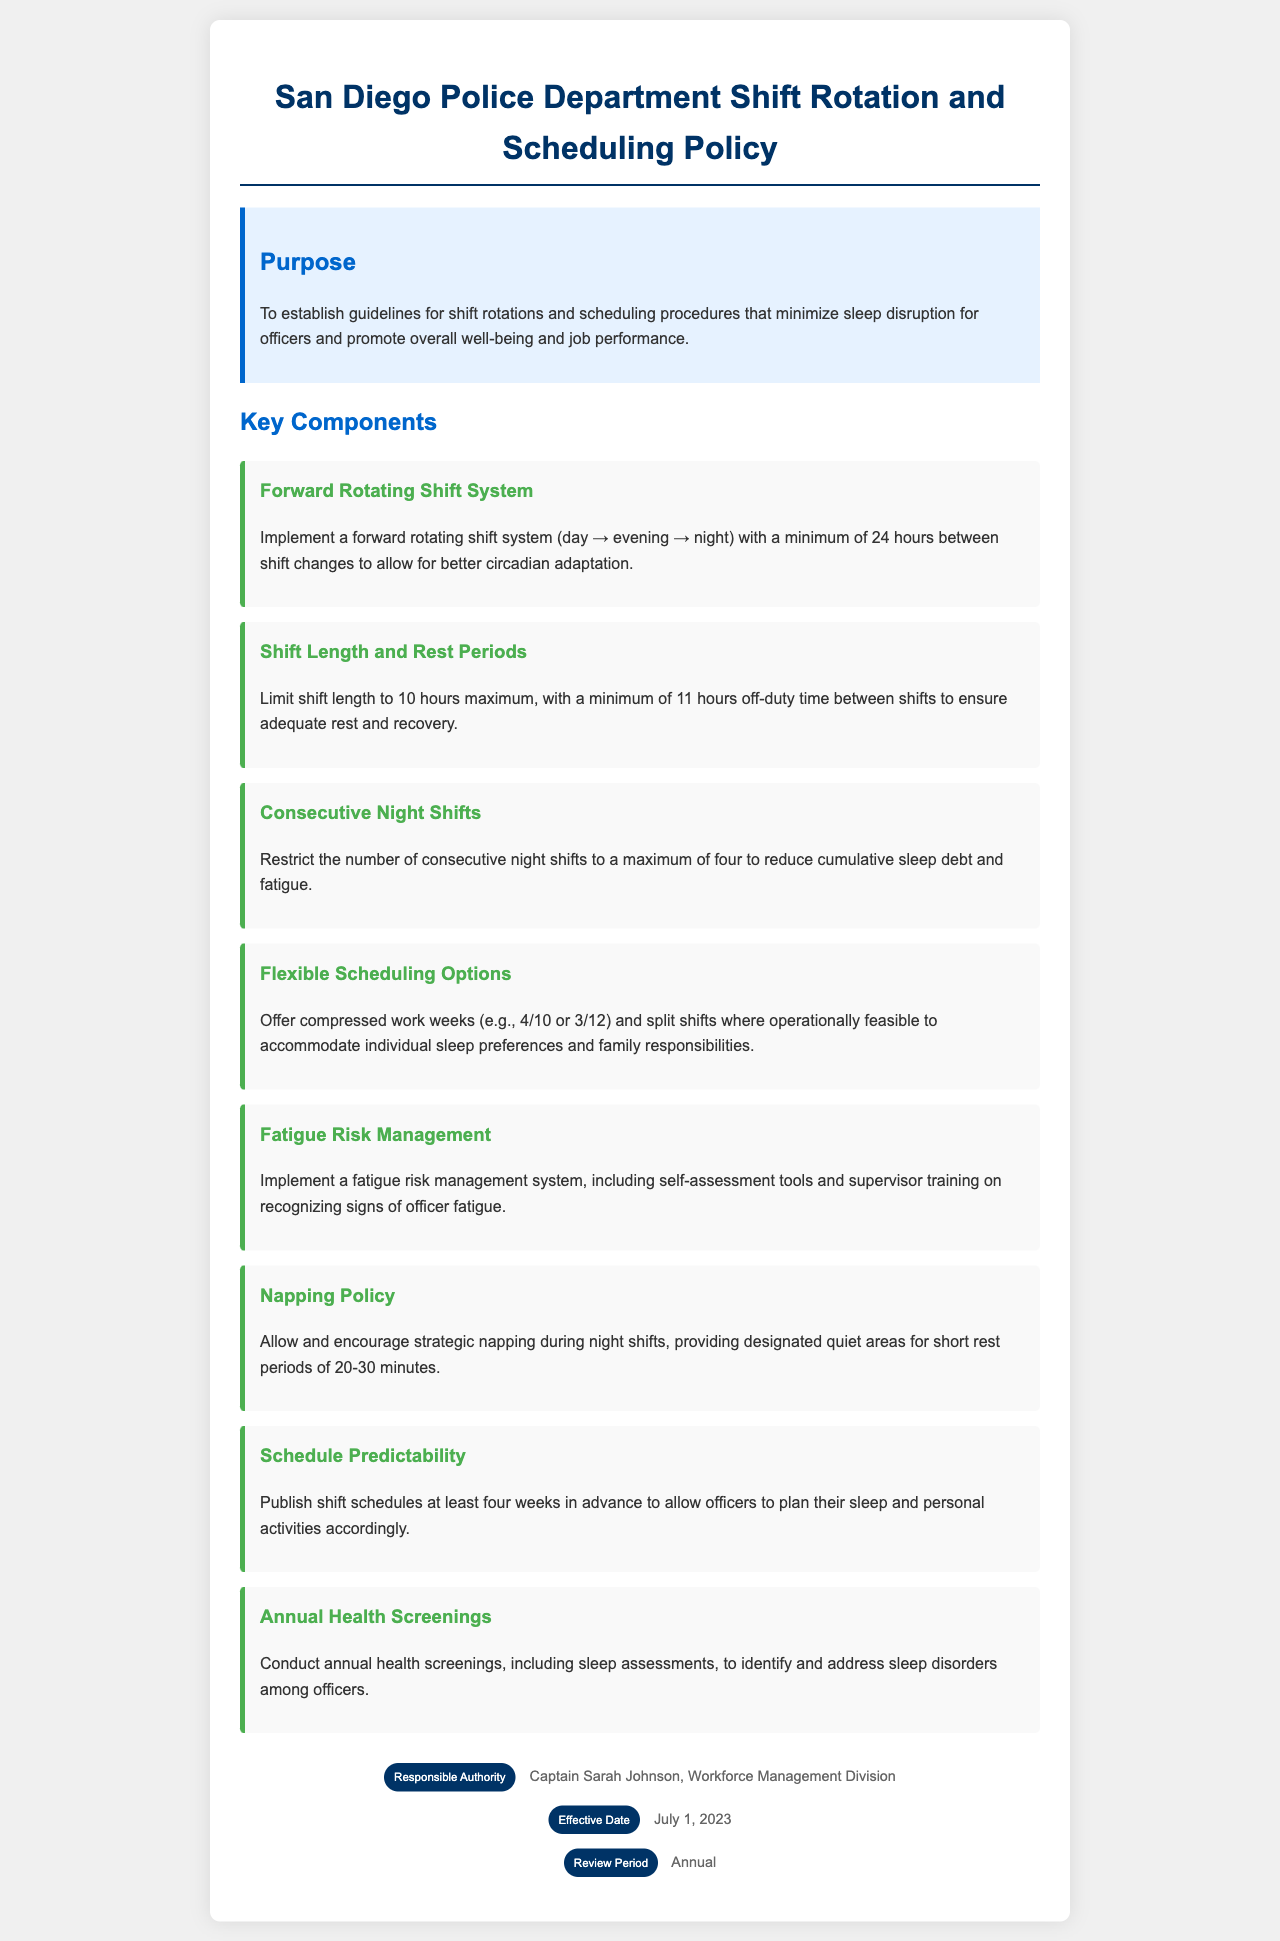What is the purpose of the policy? The purpose of the policy is to establish guidelines for shift rotations and scheduling procedures that minimize sleep disruption for officers and promote overall well-being and job performance.
Answer: To establish guidelines for shift rotations and scheduling procedures that minimize sleep disruption for officers and promote overall well-being and job performance What is the maximum length of a shift? The document specifies the maximum length of a shift to be 10 hours.
Answer: 10 hours How many consecutive night shifts are restricted? The policy restricts the number of consecutive night shifts to a maximum of four.
Answer: Four What is the minimum off-duty time between shifts? The required minimum off-duty time between shifts is 11 hours, as stated in the policy.
Answer: 11 hours When will the schedule be published? The policy states that shift schedules will be published at least four weeks in advance.
Answer: Four weeks What type of napping policy is implemented? The document mentions that strategic napping during night shifts is allowed and encouraged.
Answer: Strategic napping Who is the responsible authority for this policy? The responsible authority as mentioned in the policy document is Captain Sarah Johnson.
Answer: Captain Sarah Johnson What is the effective date of this policy? The effective date of the policy is stated as July 1, 2023.
Answer: July 1, 2023 How often are annual health screenings conducted? The policy states that annual health screenings, including sleep assessments, are conducted.
Answer: Annual What system is implemented for fatigue risk management? The document mentions the implementation of a fatigue risk management system, including self-assessment tools.
Answer: Fatigue risk management system 